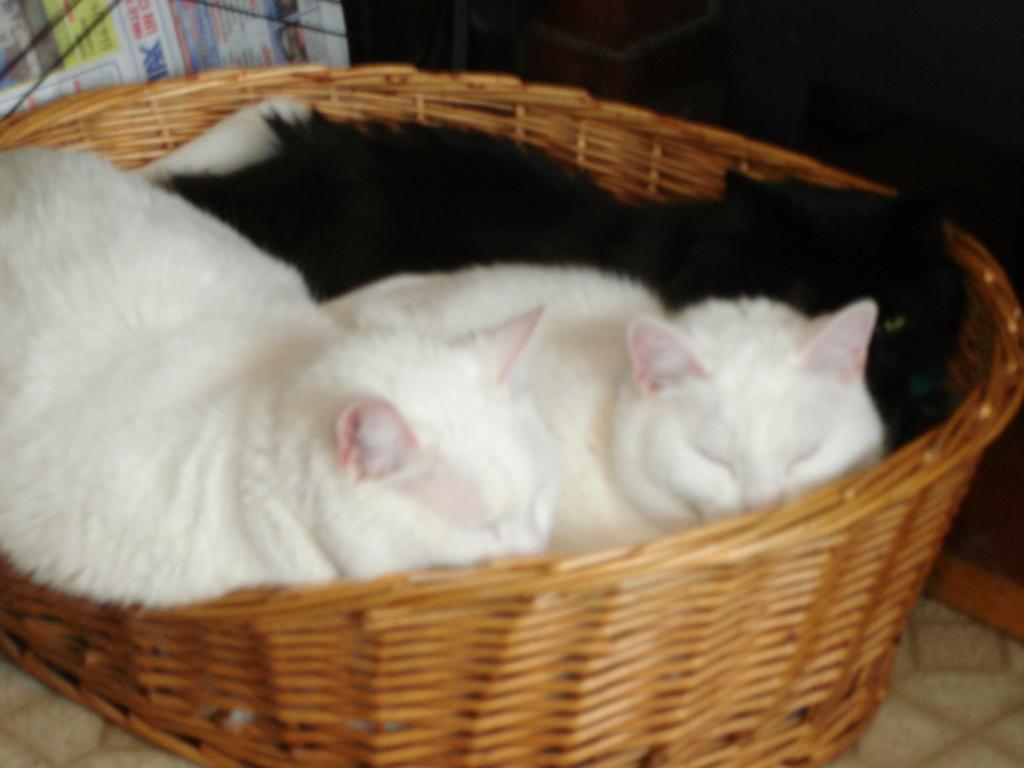Could you give a brief overview of what you see in this image? In this image, we can see three cats are in the basket. This basket is placed on the surface. Here there is a newspaper. 